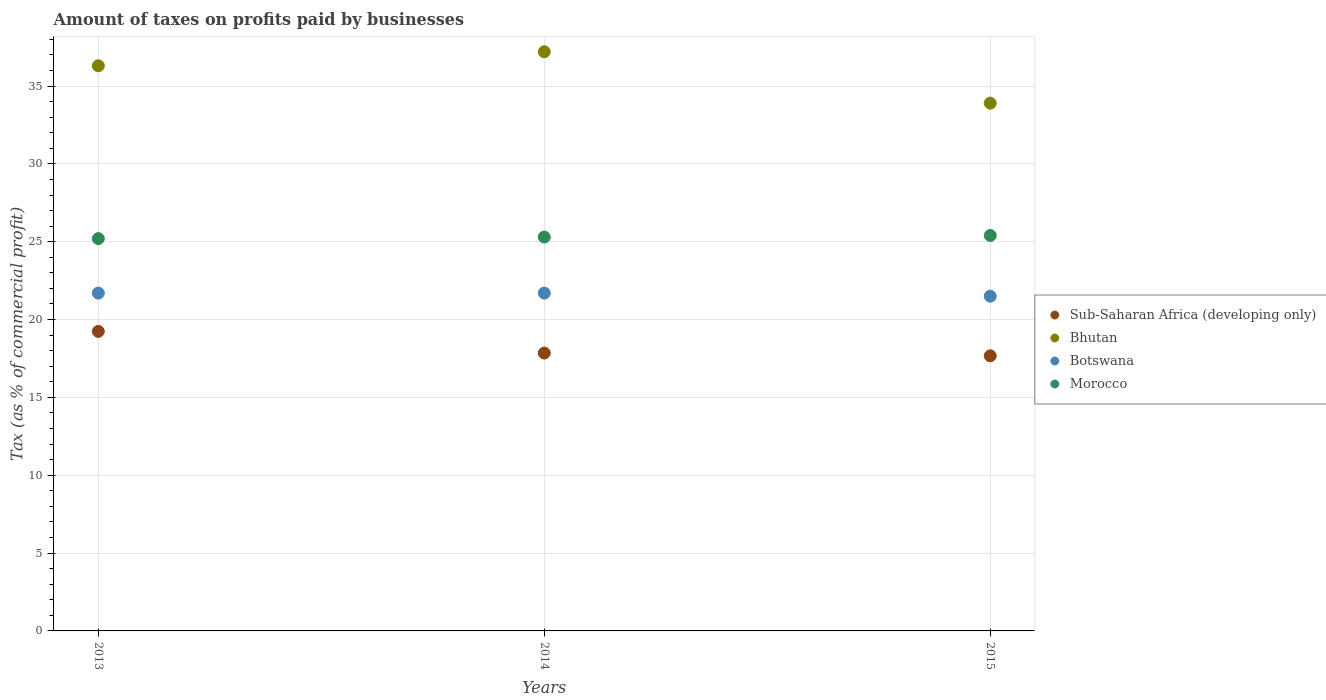Is the number of dotlines equal to the number of legend labels?
Make the answer very short. Yes. What is the percentage of taxes paid by businesses in Morocco in 2014?
Provide a succinct answer. 25.3. Across all years, what is the maximum percentage of taxes paid by businesses in Bhutan?
Ensure brevity in your answer.  37.2. Across all years, what is the minimum percentage of taxes paid by businesses in Bhutan?
Your answer should be compact. 33.9. In which year was the percentage of taxes paid by businesses in Sub-Saharan Africa (developing only) maximum?
Your answer should be very brief. 2013. In which year was the percentage of taxes paid by businesses in Sub-Saharan Africa (developing only) minimum?
Keep it short and to the point. 2015. What is the total percentage of taxes paid by businesses in Bhutan in the graph?
Your response must be concise. 107.4. What is the difference between the percentage of taxes paid by businesses in Botswana in 2013 and that in 2014?
Your answer should be compact. 0. What is the average percentage of taxes paid by businesses in Botswana per year?
Offer a very short reply. 21.63. In the year 2013, what is the difference between the percentage of taxes paid by businesses in Morocco and percentage of taxes paid by businesses in Bhutan?
Make the answer very short. -11.1. What is the ratio of the percentage of taxes paid by businesses in Bhutan in 2014 to that in 2015?
Keep it short and to the point. 1.1. Is the percentage of taxes paid by businesses in Sub-Saharan Africa (developing only) in 2013 less than that in 2014?
Offer a very short reply. No. Is the difference between the percentage of taxes paid by businesses in Morocco in 2013 and 2015 greater than the difference between the percentage of taxes paid by businesses in Bhutan in 2013 and 2015?
Ensure brevity in your answer.  No. What is the difference between the highest and the second highest percentage of taxes paid by businesses in Sub-Saharan Africa (developing only)?
Your answer should be very brief. 1.39. What is the difference between the highest and the lowest percentage of taxes paid by businesses in Morocco?
Provide a succinct answer. 0.2. Does the percentage of taxes paid by businesses in Botswana monotonically increase over the years?
Your response must be concise. No. Is the percentage of taxes paid by businesses in Bhutan strictly greater than the percentage of taxes paid by businesses in Botswana over the years?
Provide a succinct answer. Yes. How many dotlines are there?
Provide a succinct answer. 4. How many years are there in the graph?
Your answer should be very brief. 3. Are the values on the major ticks of Y-axis written in scientific E-notation?
Give a very brief answer. No. Does the graph contain any zero values?
Provide a succinct answer. No. Does the graph contain grids?
Your response must be concise. Yes. How are the legend labels stacked?
Give a very brief answer. Vertical. What is the title of the graph?
Provide a short and direct response. Amount of taxes on profits paid by businesses. What is the label or title of the X-axis?
Your answer should be compact. Years. What is the label or title of the Y-axis?
Offer a very short reply. Tax (as % of commercial profit). What is the Tax (as % of commercial profit) of Sub-Saharan Africa (developing only) in 2013?
Your answer should be very brief. 19.24. What is the Tax (as % of commercial profit) of Bhutan in 2013?
Offer a terse response. 36.3. What is the Tax (as % of commercial profit) of Botswana in 2013?
Give a very brief answer. 21.7. What is the Tax (as % of commercial profit) of Morocco in 2013?
Offer a terse response. 25.2. What is the Tax (as % of commercial profit) in Sub-Saharan Africa (developing only) in 2014?
Offer a terse response. 17.85. What is the Tax (as % of commercial profit) of Bhutan in 2014?
Provide a short and direct response. 37.2. What is the Tax (as % of commercial profit) in Botswana in 2014?
Offer a very short reply. 21.7. What is the Tax (as % of commercial profit) of Morocco in 2014?
Provide a short and direct response. 25.3. What is the Tax (as % of commercial profit) of Sub-Saharan Africa (developing only) in 2015?
Make the answer very short. 17.67. What is the Tax (as % of commercial profit) of Bhutan in 2015?
Offer a terse response. 33.9. What is the Tax (as % of commercial profit) in Morocco in 2015?
Your answer should be compact. 25.4. Across all years, what is the maximum Tax (as % of commercial profit) in Sub-Saharan Africa (developing only)?
Offer a very short reply. 19.24. Across all years, what is the maximum Tax (as % of commercial profit) in Bhutan?
Ensure brevity in your answer.  37.2. Across all years, what is the maximum Tax (as % of commercial profit) in Botswana?
Ensure brevity in your answer.  21.7. Across all years, what is the maximum Tax (as % of commercial profit) of Morocco?
Provide a succinct answer. 25.4. Across all years, what is the minimum Tax (as % of commercial profit) in Sub-Saharan Africa (developing only)?
Keep it short and to the point. 17.67. Across all years, what is the minimum Tax (as % of commercial profit) in Bhutan?
Offer a very short reply. 33.9. Across all years, what is the minimum Tax (as % of commercial profit) in Morocco?
Your answer should be compact. 25.2. What is the total Tax (as % of commercial profit) of Sub-Saharan Africa (developing only) in the graph?
Keep it short and to the point. 54.76. What is the total Tax (as % of commercial profit) of Bhutan in the graph?
Your response must be concise. 107.4. What is the total Tax (as % of commercial profit) of Botswana in the graph?
Provide a succinct answer. 64.9. What is the total Tax (as % of commercial profit) of Morocco in the graph?
Offer a very short reply. 75.9. What is the difference between the Tax (as % of commercial profit) in Sub-Saharan Africa (developing only) in 2013 and that in 2014?
Offer a very short reply. 1.39. What is the difference between the Tax (as % of commercial profit) of Bhutan in 2013 and that in 2014?
Ensure brevity in your answer.  -0.9. What is the difference between the Tax (as % of commercial profit) of Sub-Saharan Africa (developing only) in 2013 and that in 2015?
Your response must be concise. 1.57. What is the difference between the Tax (as % of commercial profit) in Morocco in 2013 and that in 2015?
Make the answer very short. -0.2. What is the difference between the Tax (as % of commercial profit) of Sub-Saharan Africa (developing only) in 2014 and that in 2015?
Your response must be concise. 0.18. What is the difference between the Tax (as % of commercial profit) of Bhutan in 2014 and that in 2015?
Your answer should be compact. 3.3. What is the difference between the Tax (as % of commercial profit) of Botswana in 2014 and that in 2015?
Provide a short and direct response. 0.2. What is the difference between the Tax (as % of commercial profit) of Sub-Saharan Africa (developing only) in 2013 and the Tax (as % of commercial profit) of Bhutan in 2014?
Provide a short and direct response. -17.96. What is the difference between the Tax (as % of commercial profit) of Sub-Saharan Africa (developing only) in 2013 and the Tax (as % of commercial profit) of Botswana in 2014?
Give a very brief answer. -2.46. What is the difference between the Tax (as % of commercial profit) of Sub-Saharan Africa (developing only) in 2013 and the Tax (as % of commercial profit) of Morocco in 2014?
Keep it short and to the point. -6.06. What is the difference between the Tax (as % of commercial profit) of Bhutan in 2013 and the Tax (as % of commercial profit) of Botswana in 2014?
Provide a succinct answer. 14.6. What is the difference between the Tax (as % of commercial profit) in Bhutan in 2013 and the Tax (as % of commercial profit) in Morocco in 2014?
Provide a succinct answer. 11. What is the difference between the Tax (as % of commercial profit) of Botswana in 2013 and the Tax (as % of commercial profit) of Morocco in 2014?
Your response must be concise. -3.6. What is the difference between the Tax (as % of commercial profit) in Sub-Saharan Africa (developing only) in 2013 and the Tax (as % of commercial profit) in Bhutan in 2015?
Keep it short and to the point. -14.66. What is the difference between the Tax (as % of commercial profit) in Sub-Saharan Africa (developing only) in 2013 and the Tax (as % of commercial profit) in Botswana in 2015?
Provide a succinct answer. -2.26. What is the difference between the Tax (as % of commercial profit) of Sub-Saharan Africa (developing only) in 2013 and the Tax (as % of commercial profit) of Morocco in 2015?
Make the answer very short. -6.16. What is the difference between the Tax (as % of commercial profit) of Sub-Saharan Africa (developing only) in 2014 and the Tax (as % of commercial profit) of Bhutan in 2015?
Your answer should be very brief. -16.05. What is the difference between the Tax (as % of commercial profit) of Sub-Saharan Africa (developing only) in 2014 and the Tax (as % of commercial profit) of Botswana in 2015?
Offer a terse response. -3.65. What is the difference between the Tax (as % of commercial profit) of Sub-Saharan Africa (developing only) in 2014 and the Tax (as % of commercial profit) of Morocco in 2015?
Your response must be concise. -7.55. What is the difference between the Tax (as % of commercial profit) of Bhutan in 2014 and the Tax (as % of commercial profit) of Morocco in 2015?
Your answer should be very brief. 11.8. What is the average Tax (as % of commercial profit) in Sub-Saharan Africa (developing only) per year?
Your response must be concise. 18.25. What is the average Tax (as % of commercial profit) of Bhutan per year?
Give a very brief answer. 35.8. What is the average Tax (as % of commercial profit) in Botswana per year?
Keep it short and to the point. 21.63. What is the average Tax (as % of commercial profit) of Morocco per year?
Make the answer very short. 25.3. In the year 2013, what is the difference between the Tax (as % of commercial profit) of Sub-Saharan Africa (developing only) and Tax (as % of commercial profit) of Bhutan?
Give a very brief answer. -17.06. In the year 2013, what is the difference between the Tax (as % of commercial profit) of Sub-Saharan Africa (developing only) and Tax (as % of commercial profit) of Botswana?
Offer a very short reply. -2.46. In the year 2013, what is the difference between the Tax (as % of commercial profit) in Sub-Saharan Africa (developing only) and Tax (as % of commercial profit) in Morocco?
Ensure brevity in your answer.  -5.96. In the year 2013, what is the difference between the Tax (as % of commercial profit) of Bhutan and Tax (as % of commercial profit) of Botswana?
Give a very brief answer. 14.6. In the year 2013, what is the difference between the Tax (as % of commercial profit) of Bhutan and Tax (as % of commercial profit) of Morocco?
Your answer should be very brief. 11.1. In the year 2014, what is the difference between the Tax (as % of commercial profit) of Sub-Saharan Africa (developing only) and Tax (as % of commercial profit) of Bhutan?
Offer a very short reply. -19.35. In the year 2014, what is the difference between the Tax (as % of commercial profit) in Sub-Saharan Africa (developing only) and Tax (as % of commercial profit) in Botswana?
Offer a very short reply. -3.85. In the year 2014, what is the difference between the Tax (as % of commercial profit) of Sub-Saharan Africa (developing only) and Tax (as % of commercial profit) of Morocco?
Ensure brevity in your answer.  -7.45. In the year 2014, what is the difference between the Tax (as % of commercial profit) of Bhutan and Tax (as % of commercial profit) of Botswana?
Make the answer very short. 15.5. In the year 2015, what is the difference between the Tax (as % of commercial profit) of Sub-Saharan Africa (developing only) and Tax (as % of commercial profit) of Bhutan?
Your response must be concise. -16.23. In the year 2015, what is the difference between the Tax (as % of commercial profit) in Sub-Saharan Africa (developing only) and Tax (as % of commercial profit) in Botswana?
Provide a short and direct response. -3.83. In the year 2015, what is the difference between the Tax (as % of commercial profit) in Sub-Saharan Africa (developing only) and Tax (as % of commercial profit) in Morocco?
Offer a terse response. -7.73. In the year 2015, what is the difference between the Tax (as % of commercial profit) in Bhutan and Tax (as % of commercial profit) in Botswana?
Provide a succinct answer. 12.4. In the year 2015, what is the difference between the Tax (as % of commercial profit) in Bhutan and Tax (as % of commercial profit) in Morocco?
Provide a succinct answer. 8.5. What is the ratio of the Tax (as % of commercial profit) of Sub-Saharan Africa (developing only) in 2013 to that in 2014?
Offer a terse response. 1.08. What is the ratio of the Tax (as % of commercial profit) of Bhutan in 2013 to that in 2014?
Offer a very short reply. 0.98. What is the ratio of the Tax (as % of commercial profit) in Botswana in 2013 to that in 2014?
Make the answer very short. 1. What is the ratio of the Tax (as % of commercial profit) in Morocco in 2013 to that in 2014?
Ensure brevity in your answer.  1. What is the ratio of the Tax (as % of commercial profit) in Sub-Saharan Africa (developing only) in 2013 to that in 2015?
Your response must be concise. 1.09. What is the ratio of the Tax (as % of commercial profit) in Bhutan in 2013 to that in 2015?
Keep it short and to the point. 1.07. What is the ratio of the Tax (as % of commercial profit) in Botswana in 2013 to that in 2015?
Your answer should be very brief. 1.01. What is the ratio of the Tax (as % of commercial profit) in Bhutan in 2014 to that in 2015?
Offer a terse response. 1.1. What is the ratio of the Tax (as % of commercial profit) in Botswana in 2014 to that in 2015?
Provide a succinct answer. 1.01. What is the difference between the highest and the second highest Tax (as % of commercial profit) of Sub-Saharan Africa (developing only)?
Keep it short and to the point. 1.39. What is the difference between the highest and the lowest Tax (as % of commercial profit) in Sub-Saharan Africa (developing only)?
Offer a very short reply. 1.57. What is the difference between the highest and the lowest Tax (as % of commercial profit) of Bhutan?
Make the answer very short. 3.3. What is the difference between the highest and the lowest Tax (as % of commercial profit) of Botswana?
Your answer should be very brief. 0.2. What is the difference between the highest and the lowest Tax (as % of commercial profit) of Morocco?
Keep it short and to the point. 0.2. 